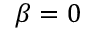Convert formula to latex. <formula><loc_0><loc_0><loc_500><loc_500>\beta = 0</formula> 